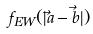<formula> <loc_0><loc_0><loc_500><loc_500>f _ { E W } ( | \vec { a } - \vec { b } | )</formula> 